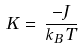<formula> <loc_0><loc_0><loc_500><loc_500>K \, = \, \frac { - J } { k _ { B } \, T }</formula> 